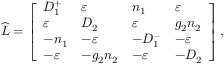Convert formula to latex. <formula><loc_0><loc_0><loc_500><loc_500>\widehat { L } = \left [ \begin{array} { l l l l } { D _ { 1 } ^ { + } } & { \varepsilon } & { n _ { 1 } } & { \varepsilon } \\ { \varepsilon } & { D _ { 2 } } & { \varepsilon } & { g _ { 2 } n _ { 2 } } \\ { - n _ { 1 } } & { - \varepsilon } & { - D _ { 1 } ^ { - } } & { - \varepsilon } \\ { - \varepsilon } & { - g _ { 2 } n _ { 2 } } & { - \varepsilon } & { - D _ { 2 } } \end{array} \right ] ,</formula> 